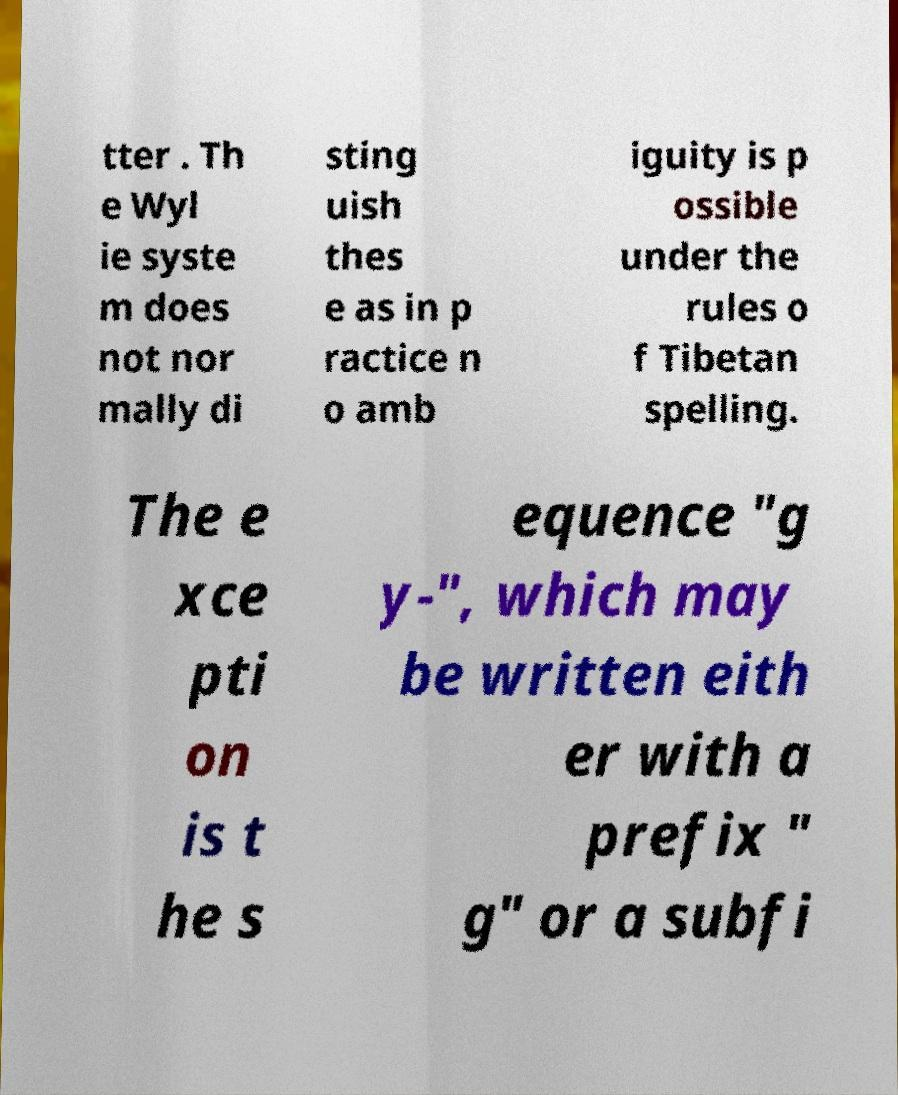Please identify and transcribe the text found in this image. tter . Th e Wyl ie syste m does not nor mally di sting uish thes e as in p ractice n o amb iguity is p ossible under the rules o f Tibetan spelling. The e xce pti on is t he s equence "g y-", which may be written eith er with a prefix " g" or a subfi 